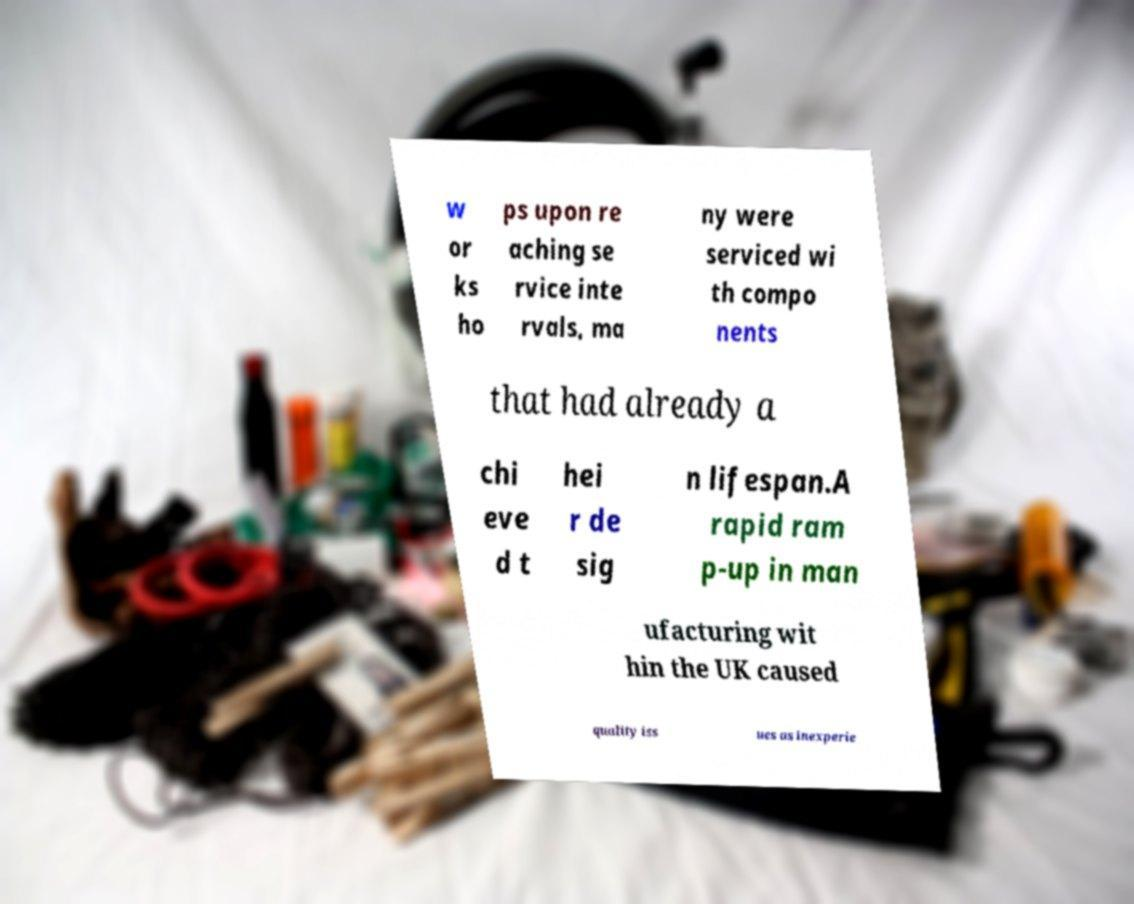Can you read and provide the text displayed in the image?This photo seems to have some interesting text. Can you extract and type it out for me? w or ks ho ps upon re aching se rvice inte rvals, ma ny were serviced wi th compo nents that had already a chi eve d t hei r de sig n lifespan.A rapid ram p-up in man ufacturing wit hin the UK caused quality iss ues as inexperie 